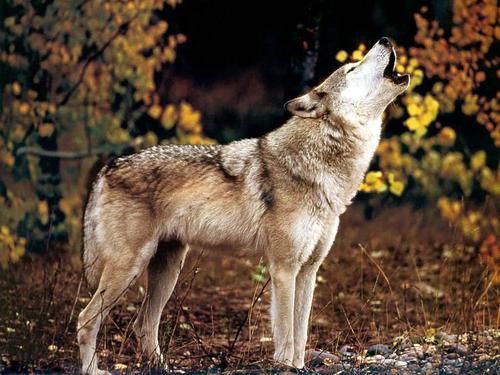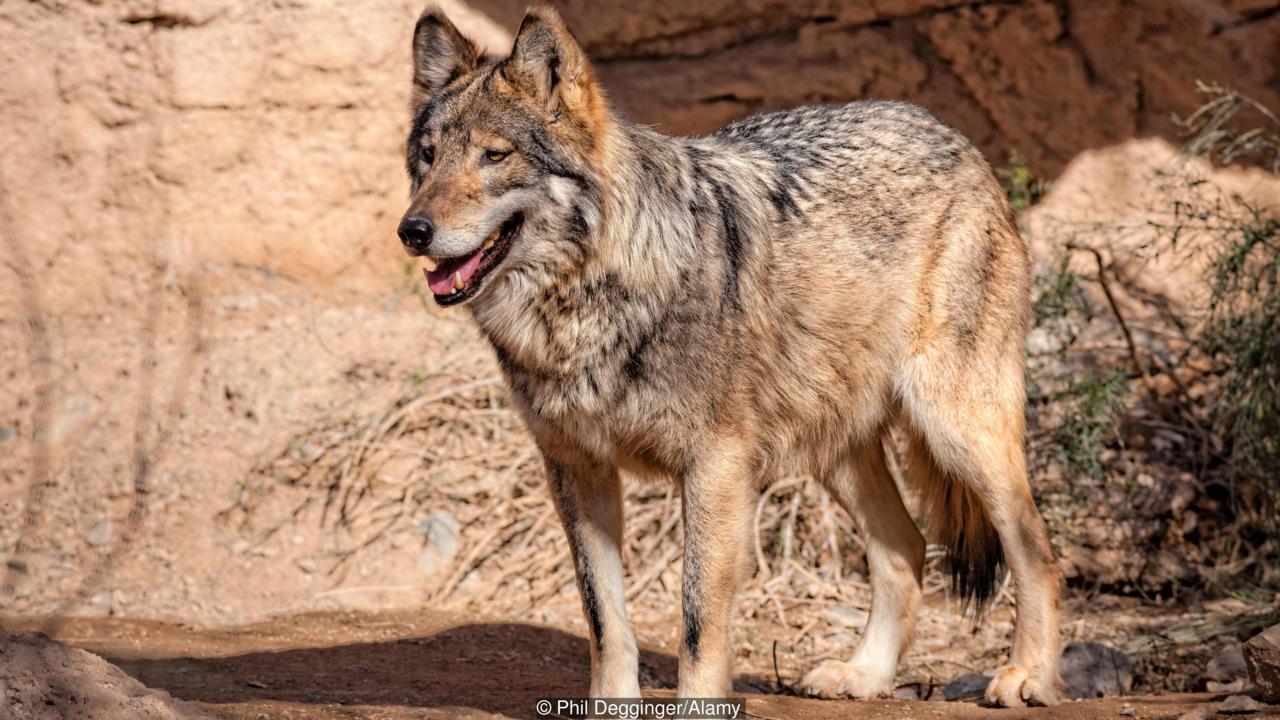The first image is the image on the left, the second image is the image on the right. Evaluate the accuracy of this statement regarding the images: "The left image contains a single standing wolf in a non-snowy setting, and the right image includes two wolves with their heads side-by-side in a scene with some snow.". Is it true? Answer yes or no. No. The first image is the image on the left, the second image is the image on the right. Examine the images to the left and right. Is the description "There are at least three wolves walking through heavy snow." accurate? Answer yes or no. No. 